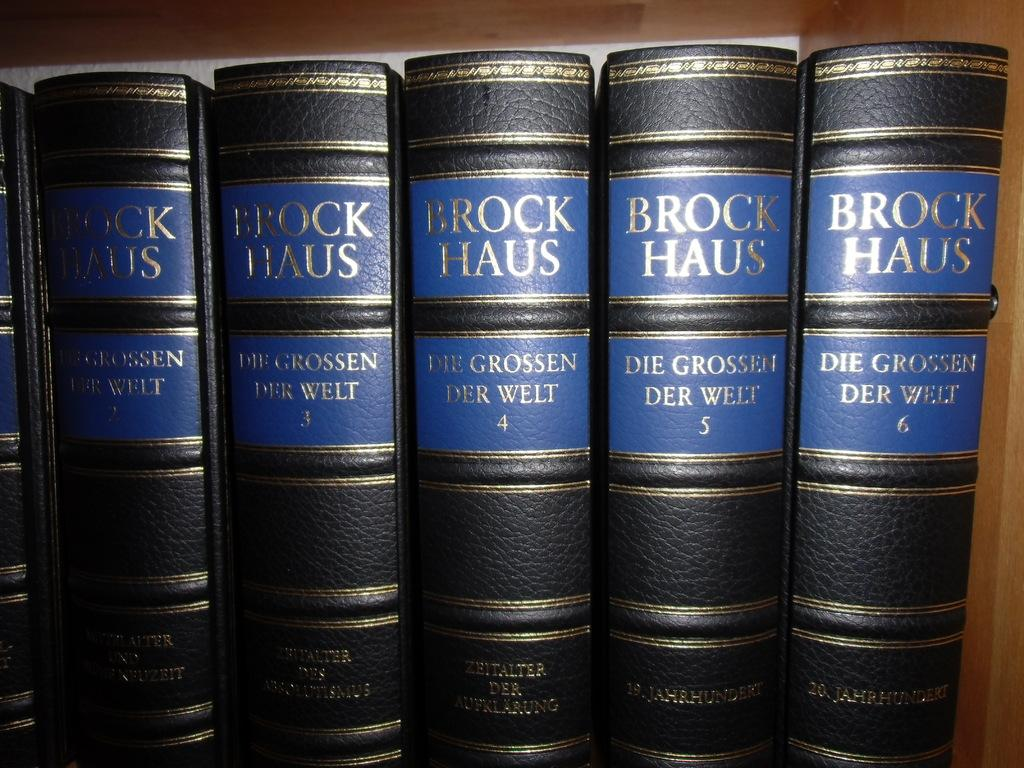<image>
Give a short and clear explanation of the subsequent image. 6 books on a shelf with the name Brock Haus on it 